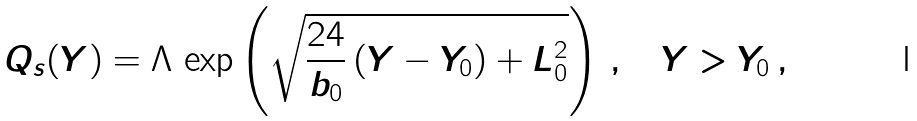Convert formula to latex. <formula><loc_0><loc_0><loc_500><loc_500>Q _ { s } ( Y ) = \Lambda \, \exp \left ( \sqrt { { \frac { 2 4 } { b _ { 0 } } } \, ( Y - Y _ { 0 } ) + L _ { 0 } ^ { 2 } } \right ) \, , \quad Y > Y _ { 0 } \, ,</formula> 